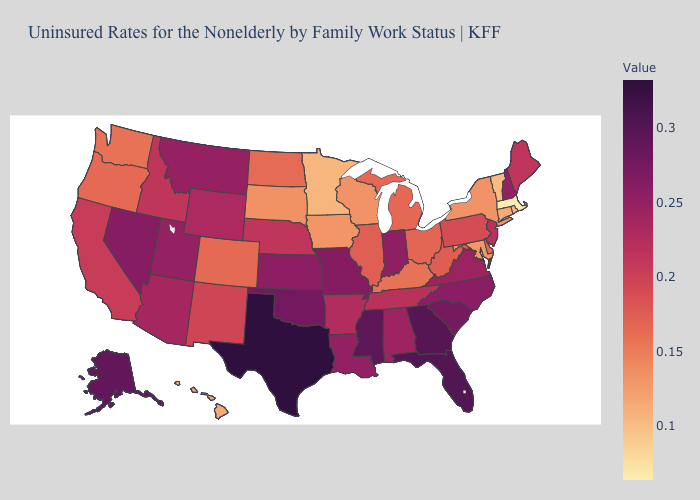Among the states that border Michigan , which have the lowest value?
Write a very short answer. Wisconsin. Does Washington have the highest value in the USA?
Answer briefly. No. Among the states that border Kansas , does Nebraska have the highest value?
Give a very brief answer. No. Which states hav the highest value in the MidWest?
Be succinct. Missouri. Among the states that border Alabama , does Tennessee have the lowest value?
Concise answer only. Yes. Does Massachusetts have the lowest value in the USA?
Write a very short answer. Yes. 